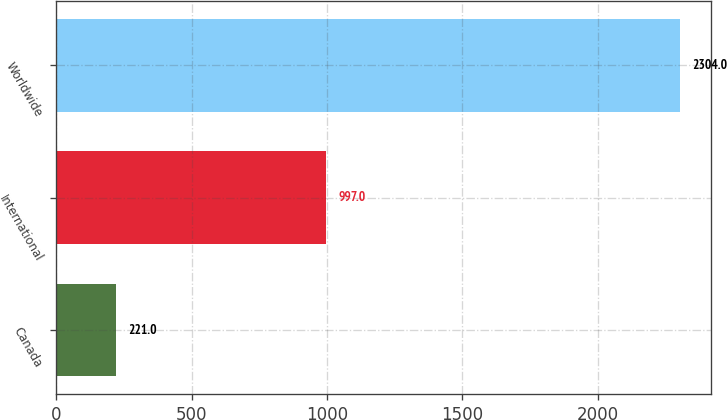Convert chart. <chart><loc_0><loc_0><loc_500><loc_500><bar_chart><fcel>Canada<fcel>International<fcel>Worldwide<nl><fcel>221<fcel>997<fcel>2304<nl></chart> 